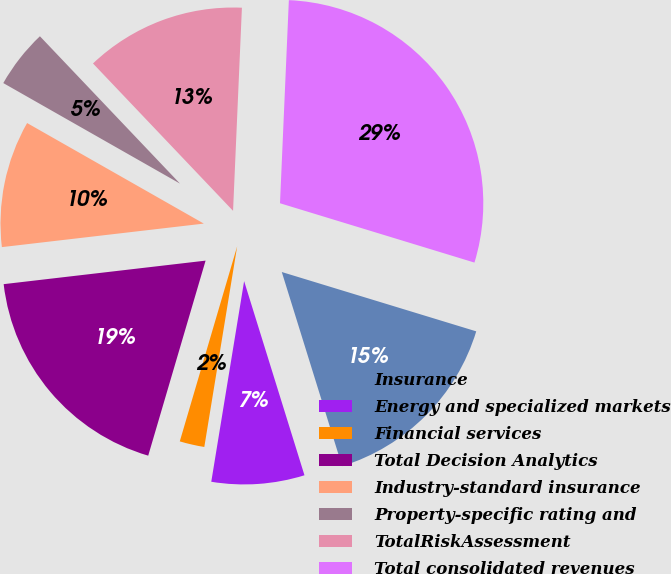<chart> <loc_0><loc_0><loc_500><loc_500><pie_chart><fcel>Insurance<fcel>Energy and specialized markets<fcel>Financial services<fcel>Total Decision Analytics<fcel>Industry-standard insurance<fcel>Property-specific rating and<fcel>TotalRiskAssessment<fcel>Total consolidated revenues<nl><fcel>15.49%<fcel>7.38%<fcel>1.97%<fcel>18.6%<fcel>10.08%<fcel>4.67%<fcel>12.79%<fcel>29.02%<nl></chart> 